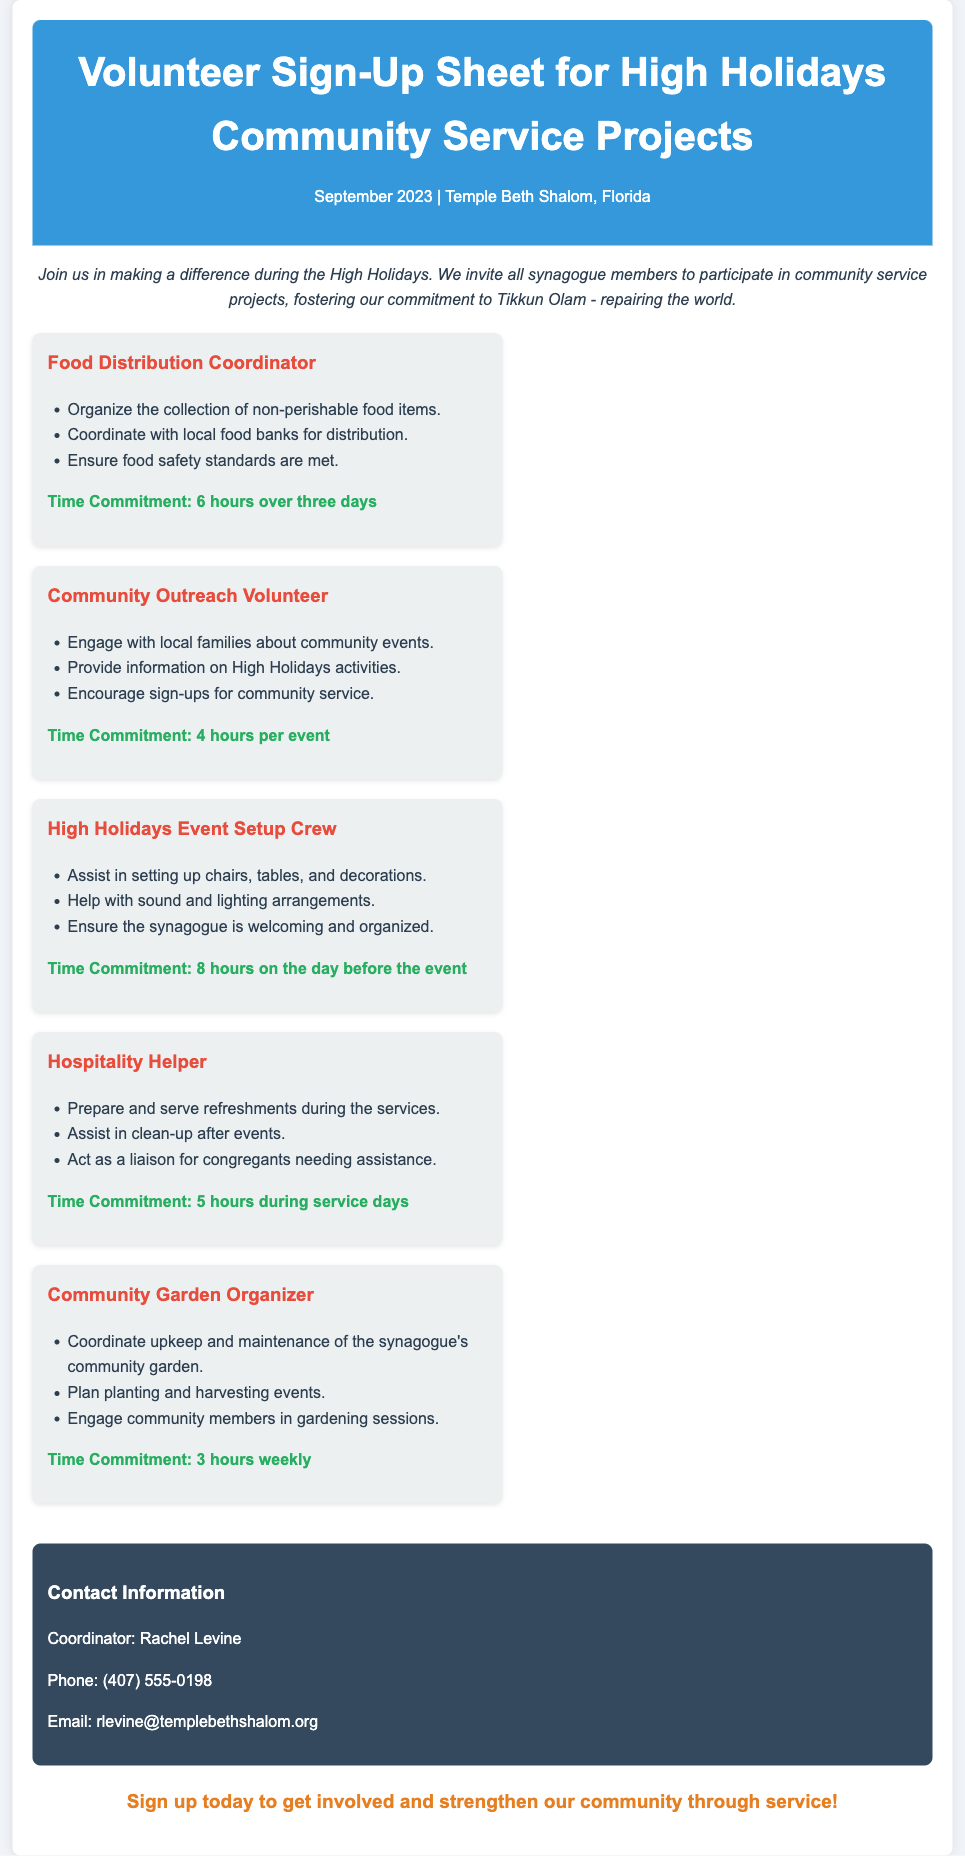what is the title of the document? The title is found in the header section of the document.
Answer: Volunteer Sign-Up Sheet for High Holidays Community Service Projects who is the contact coordinator? The contact coordinator is listed in the contact information section.
Answer: Rachel Levine how many hours is needed for the Food Distribution Coordinator role? The number of hours is specified in the time commitment section for this role.
Answer: 6 hours over three days what role requires the preparation and serving of refreshments? This role is directly mentioned in relation to serving and clean-up duties.
Answer: Hospitality Helper how often does the Community Garden Organizer role require commitment? The frequency of the commitment is detailed in the time commitment for this role.
Answer: 3 hours weekly which service role involves setting up the synagogue for events? This role is specifically mentioned for setting up chairs, tables, and decorations.
Answer: High Holidays Event Setup Crew what color is used for the heading background? The background color is described in the styling of the document.
Answer: #3498db how many hours is needed for the High Holidays Event Setup Crew? The required hours are stated in the time commitment section for this service.
Answer: 8 hours on the day before the event what is the primary purpose of the document? The main intent is stated in the descriptive text at the beginning of the document.
Answer: To invite members to participate in community service projects 